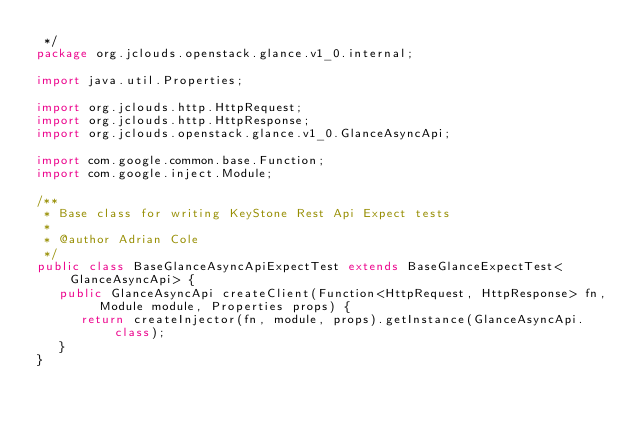Convert code to text. <code><loc_0><loc_0><loc_500><loc_500><_Java_> */
package org.jclouds.openstack.glance.v1_0.internal;

import java.util.Properties;

import org.jclouds.http.HttpRequest;
import org.jclouds.http.HttpResponse;
import org.jclouds.openstack.glance.v1_0.GlanceAsyncApi;

import com.google.common.base.Function;
import com.google.inject.Module;

/**
 * Base class for writing KeyStone Rest Api Expect tests
 * 
 * @author Adrian Cole
 */
public class BaseGlanceAsyncApiExpectTest extends BaseGlanceExpectTest<GlanceAsyncApi> {
   public GlanceAsyncApi createClient(Function<HttpRequest, HttpResponse> fn, Module module, Properties props) {
      return createInjector(fn, module, props).getInstance(GlanceAsyncApi.class);
   }
}
</code> 